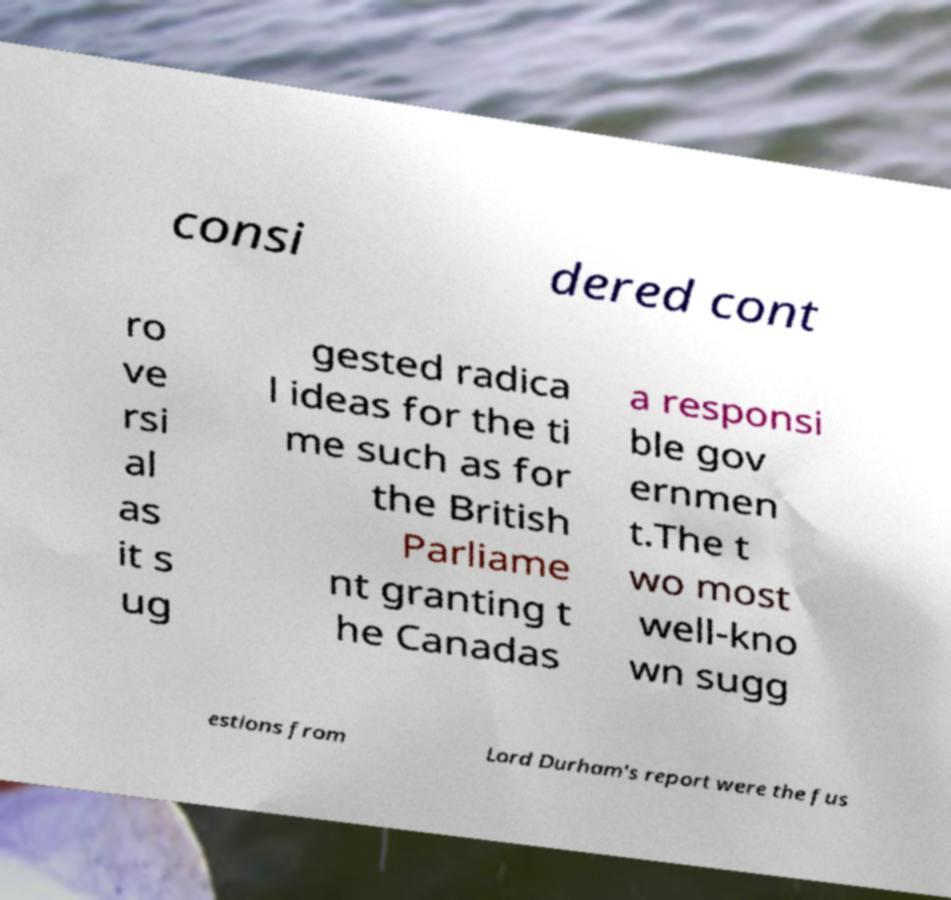Can you accurately transcribe the text from the provided image for me? consi dered cont ro ve rsi al as it s ug gested radica l ideas for the ti me such as for the British Parliame nt granting t he Canadas a responsi ble gov ernmen t.The t wo most well-kno wn sugg estions from Lord Durham's report were the fus 